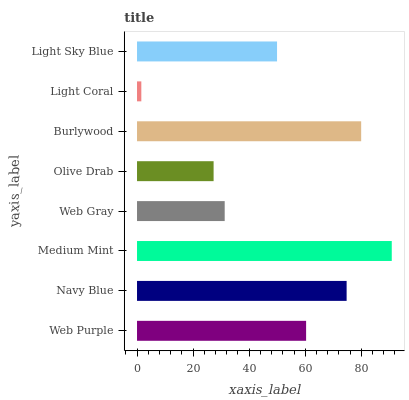Is Light Coral the minimum?
Answer yes or no. Yes. Is Medium Mint the maximum?
Answer yes or no. Yes. Is Navy Blue the minimum?
Answer yes or no. No. Is Navy Blue the maximum?
Answer yes or no. No. Is Navy Blue greater than Web Purple?
Answer yes or no. Yes. Is Web Purple less than Navy Blue?
Answer yes or no. Yes. Is Web Purple greater than Navy Blue?
Answer yes or no. No. Is Navy Blue less than Web Purple?
Answer yes or no. No. Is Web Purple the high median?
Answer yes or no. Yes. Is Light Sky Blue the low median?
Answer yes or no. Yes. Is Olive Drab the high median?
Answer yes or no. No. Is Web Gray the low median?
Answer yes or no. No. 